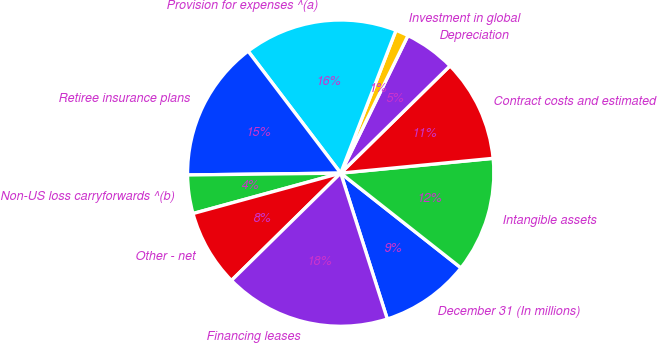Convert chart to OTSL. <chart><loc_0><loc_0><loc_500><loc_500><pie_chart><fcel>December 31 (In millions)<fcel>Intangible assets<fcel>Contract costs and estimated<fcel>Depreciation<fcel>Investment in global<fcel>Provision for expenses ^(a)<fcel>Retiree insurance plans<fcel>Non-US loss carryforwards ^(b)<fcel>Other - net<fcel>Financing leases<nl><fcel>9.46%<fcel>12.16%<fcel>10.81%<fcel>5.41%<fcel>1.36%<fcel>16.21%<fcel>14.86%<fcel>4.06%<fcel>8.11%<fcel>17.56%<nl></chart> 